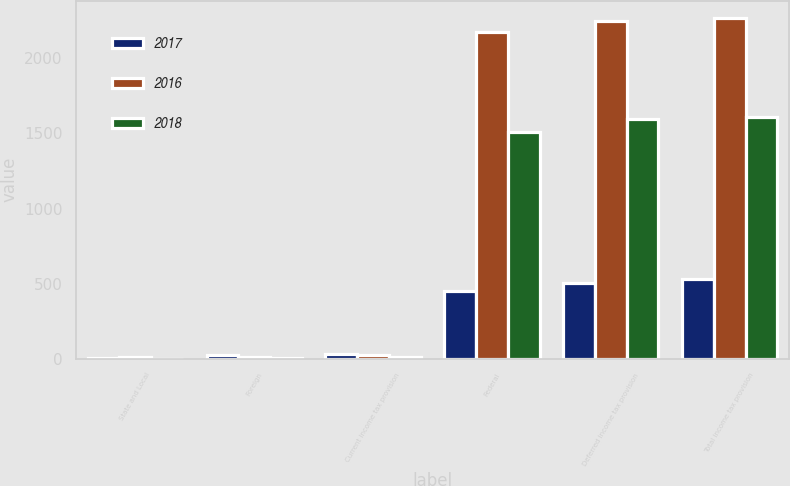Convert chart to OTSL. <chart><loc_0><loc_0><loc_500><loc_500><stacked_bar_chart><ecel><fcel>State and Local<fcel>Foreign<fcel>Current income tax provision<fcel>Federal<fcel>Deferred income tax provision<fcel>Total income tax provision<nl><fcel>2017<fcel>3<fcel>28<fcel>31<fcel>453<fcel>503<fcel>534<nl><fcel>2016<fcel>14<fcel>10<fcel>24<fcel>2176<fcel>2246<fcel>2270<nl><fcel>2018<fcel>1<fcel>9<fcel>10<fcel>1507<fcel>1597<fcel>1607<nl></chart> 